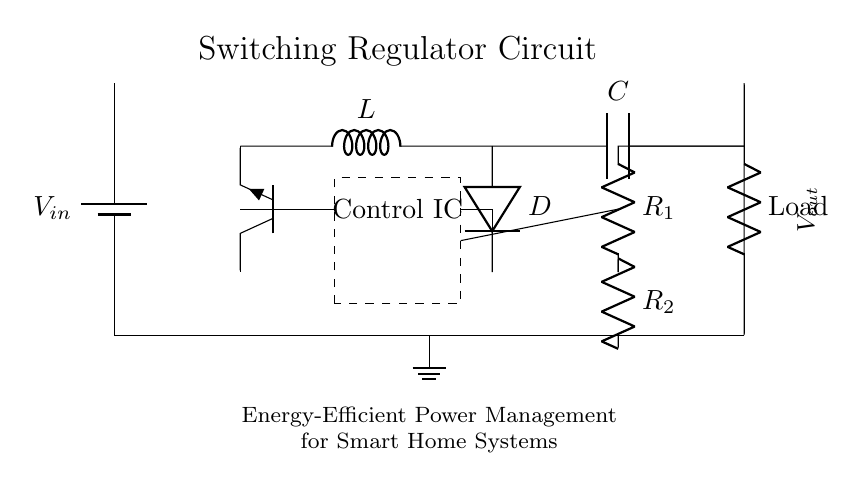What is the type of transistor used in this circuit? The circuit uses a NPN transistor, as indicated by the label 'Tnpn' on the transistor symbol.
Answer: NPN What is connected to the output of the regulator? The output connects to a load resistor, indicated by 'R' in the circuit diagram, which is typically where output power is delivered.
Answer: Load What is the purpose of the inductor labeled 'L'? The inductor 'L' in the switching regulator helps smooth out the current and store energy when the transistor is turned on.
Answer: Energy storage What are the two resistors in the feedback network called? The feedback network comprises two resistors labeled 'R1' and 'R2', which are important for setting the output voltage regulation.
Answer: R1 and R2 What would happen if the diode labeled 'D' was removed from the circuit? If the diode 'D' is removed, the circuit would not be able to prevent backflow of current, likely leading to circuit malfunction or damage.
Answer: Circuit malfunction What does the dashed rectangle labeled 'Control IC' signify? The dashed rectangle represents a control integrated circuit, which regulates the operation of the switching regulator by controlling the switching of the transistor.
Answer: Control IC What is the purpose of the capacitor labeled 'C' in this circuit? The capacitor 'C' is used to filter the output voltage and maintain stability in the voltage supplied to the load by smoothing any fluctuations.
Answer: Voltage smoothing 